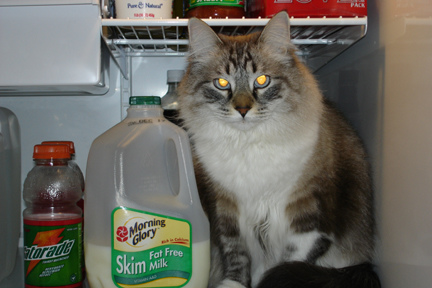<image>Where is the cat staring at? It is not sure where the cat is staring at. It might be staring at the camera or the photographer. Where is the cat staring at? I don't know where the cat is staring at. It seems like it is looking at the camera or the photographer. 